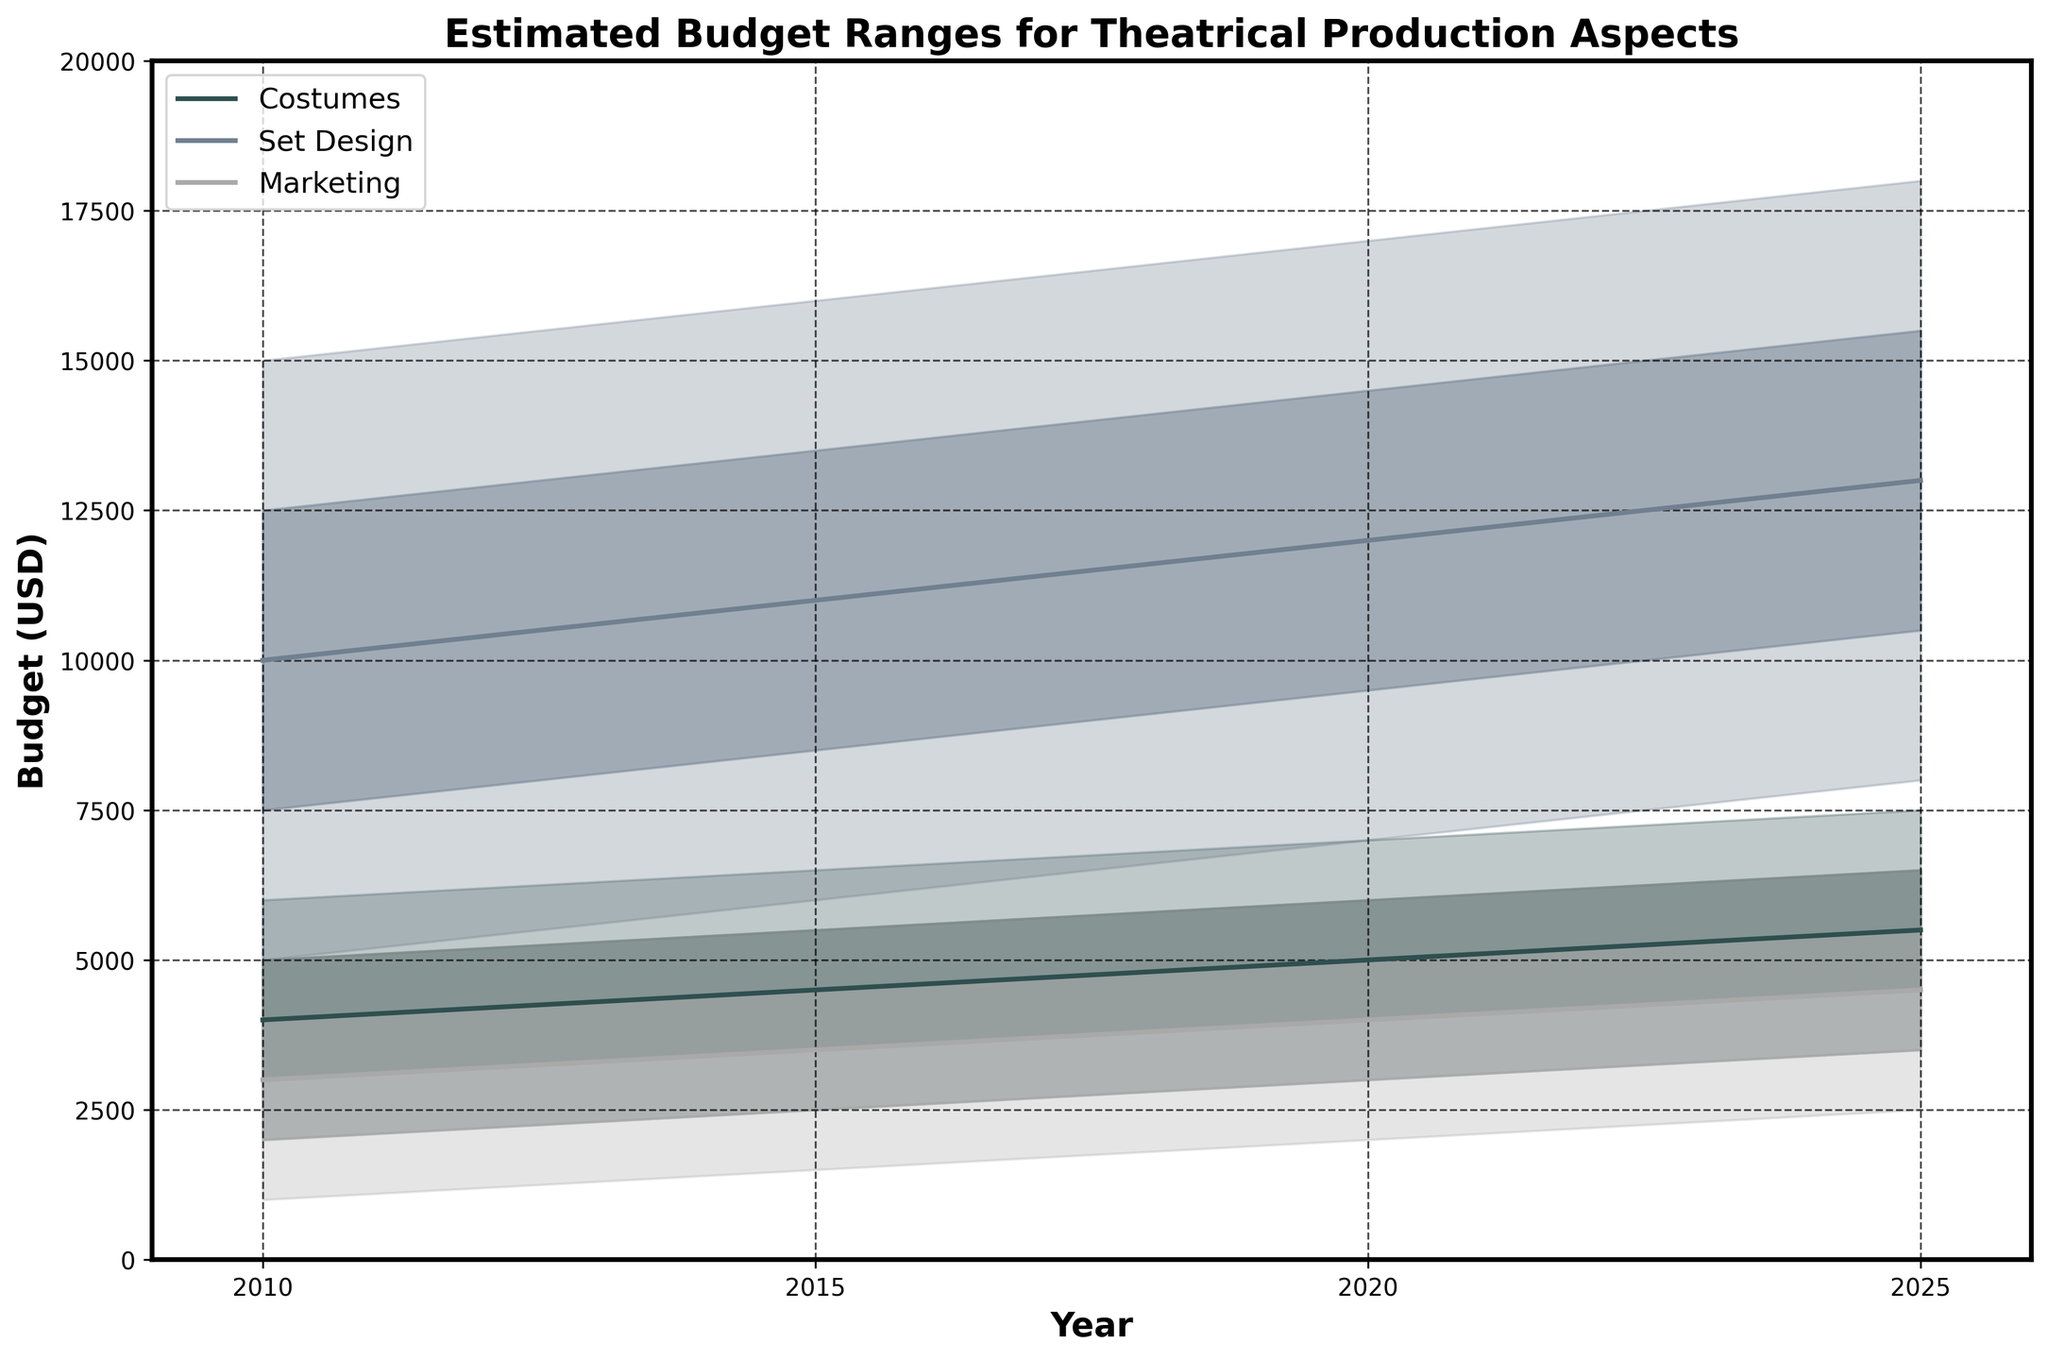What is the title of the chart? The title of the chart is clearly written at the top of the graph. It is usually in a larger or bolder font to easily identify the main subject of the chart.
Answer: "Estimated Budget Ranges for Theatrical Production Aspects" What time period does the chart cover? By looking at the x-axis, you can see the range of years indicated. The starting year is at one end, and the ending year is at the other end of the x-axis.
Answer: 2010 to 2025 What aspect has the highest estimated budget in 2025 according to the median value? To find this, look at the mid-values for each aspect in 2025. Compare 'Costumes,' 'Set Design,' and 'Marketing.' The highest median value is the answer.
Answer: Set Design Which budget category for Marketing has the smallest increase from 2010 to 2025? Examine the values for 'Marketing' in 2010 and in 2025. Calculate the differences for 'Low,' 'LowMid,' 'Mid,' 'HighMid,' and 'High,' then identify the smallest change.
Answer: High By how much did the 'LowMid' value for Costumes increase from 2010 to 2025? Look at the 'LowMid' value for Costumes in 2010 and 2025, then subtract the former from the latter: 4500 - 3000.
Answer: 1500 Which aspect saw the highest increase in its 'HighMid' value between 2010 and 2025? Calculate the differences in 'HighMid' values for all aspects between 2010 and 2025. The aspect with the highest difference is the answer.
Answer: Set Design How has the range of estimated budgets for Marketing changed from 2010 to 2025? For 'Marketing,' compare the range of values from lowest to highest in 2010 and 2025. Determine how the range has shifted by comparing the "Low" and "High" values in each year.
Answer: Increased Is the high estimate for Set Design in 2020 less than the high estimate for Costumes in 2025? Compare the 'High' value for Set Design in 2020 and the 'High' value for Costumes in 2025. Check whether the former is less than the latter.
Answer: Yes Which year shows the widest range of estimated budgets for Costumes? To find this, look at the range from 'Low' to 'High' for Costumes in each year. Identify the year with the largest difference between these two values.
Answer: 2025 What is the average 'Mid' value for Set Design over the years presented? Calculate the 'Mid' values for Set Design in 2010, 2015, 2020, and 2025. Then, compute the average by summing these values and dividing by the number of years, (10000 + 11000 + 12000 + 13000) / 4.
Answer: 11500 